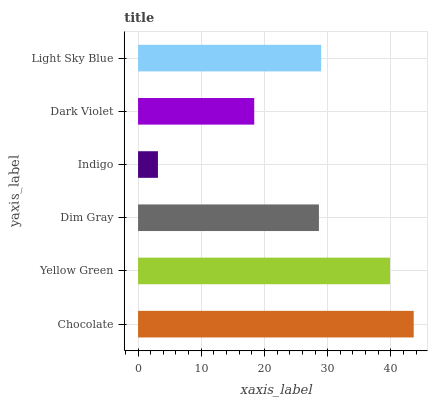Is Indigo the minimum?
Answer yes or no. Yes. Is Chocolate the maximum?
Answer yes or no. Yes. Is Yellow Green the minimum?
Answer yes or no. No. Is Yellow Green the maximum?
Answer yes or no. No. Is Chocolate greater than Yellow Green?
Answer yes or no. Yes. Is Yellow Green less than Chocolate?
Answer yes or no. Yes. Is Yellow Green greater than Chocolate?
Answer yes or no. No. Is Chocolate less than Yellow Green?
Answer yes or no. No. Is Light Sky Blue the high median?
Answer yes or no. Yes. Is Dim Gray the low median?
Answer yes or no. Yes. Is Chocolate the high median?
Answer yes or no. No. Is Indigo the low median?
Answer yes or no. No. 